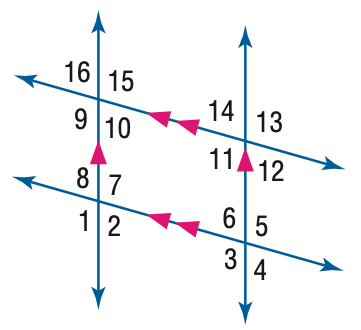Answer the mathemtical geometry problem and directly provide the correct option letter.
Question: In the figure, m \angle 1 = 123. Find the measure of \angle 5.
Choices: A: 47 B: 57 C: 67 D: 123 D 